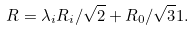<formula> <loc_0><loc_0><loc_500><loc_500>R = \lambda _ { i } R _ { i } / \sqrt { 2 } + R _ { 0 } / \sqrt { 3 } 1 .</formula> 